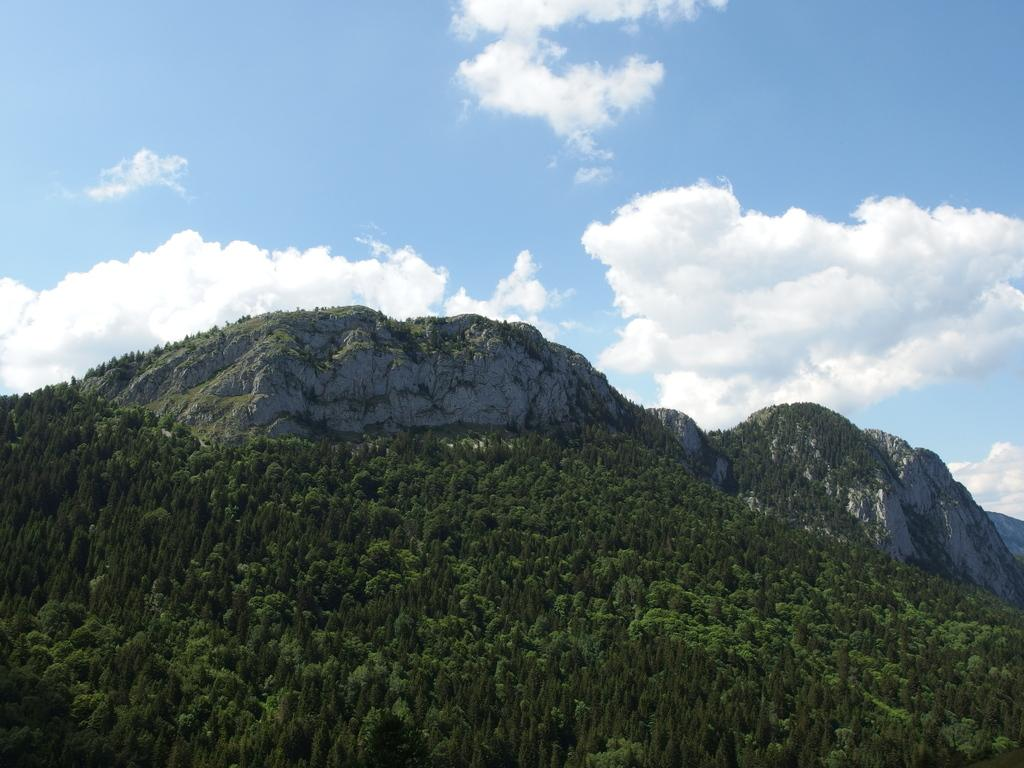What type of vegetation is at the bottom of the image? There are trees at the bottom of the image. What geographical features can be seen in the background of the image? Many hills are visible in the background of the image. What is visible at the top of the image? The sky is visible at the top of the image. What can be seen in the sky? Clouds are present in the sky. Where is the tent located in the image? There is no tent present in the image. Who is taking a picture with the camera in the image? There is no camera or person taking a picture in the image. 